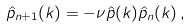Convert formula to latex. <formula><loc_0><loc_0><loc_500><loc_500>\hat { p } _ { n + 1 } ( k ) = - \nu \hat { p } ( k ) \hat { p } _ { n } ( k ) \, ,</formula> 